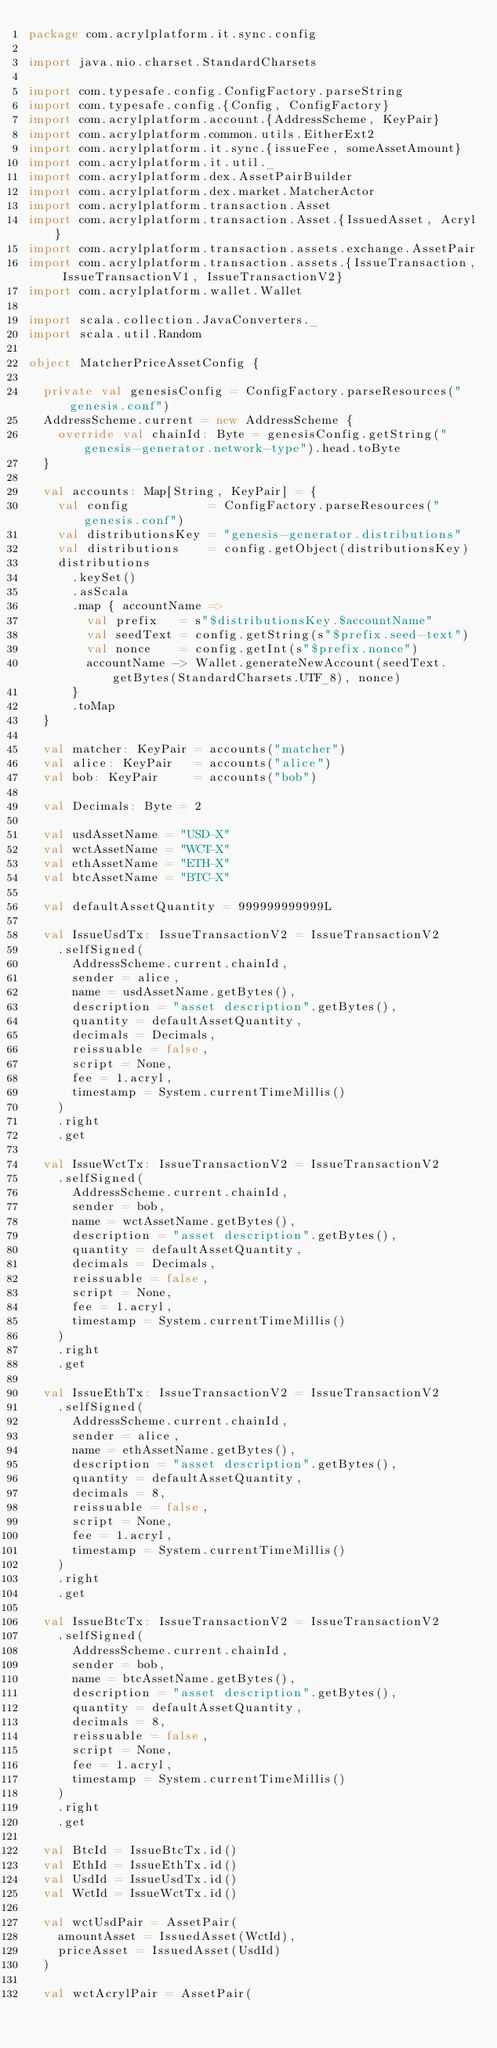Convert code to text. <code><loc_0><loc_0><loc_500><loc_500><_Scala_>package com.acrylplatform.it.sync.config

import java.nio.charset.StandardCharsets

import com.typesafe.config.ConfigFactory.parseString
import com.typesafe.config.{Config, ConfigFactory}
import com.acrylplatform.account.{AddressScheme, KeyPair}
import com.acrylplatform.common.utils.EitherExt2
import com.acrylplatform.it.sync.{issueFee, someAssetAmount}
import com.acrylplatform.it.util._
import com.acrylplatform.dex.AssetPairBuilder
import com.acrylplatform.dex.market.MatcherActor
import com.acrylplatform.transaction.Asset
import com.acrylplatform.transaction.Asset.{IssuedAsset, Acryl}
import com.acrylplatform.transaction.assets.exchange.AssetPair
import com.acrylplatform.transaction.assets.{IssueTransaction, IssueTransactionV1, IssueTransactionV2}
import com.acrylplatform.wallet.Wallet

import scala.collection.JavaConverters._
import scala.util.Random

object MatcherPriceAssetConfig {

  private val genesisConfig = ConfigFactory.parseResources("genesis.conf")
  AddressScheme.current = new AddressScheme {
    override val chainId: Byte = genesisConfig.getString("genesis-generator.network-type").head.toByte
  }

  val accounts: Map[String, KeyPair] = {
    val config           = ConfigFactory.parseResources("genesis.conf")
    val distributionsKey = "genesis-generator.distributions"
    val distributions    = config.getObject(distributionsKey)
    distributions
      .keySet()
      .asScala
      .map { accountName =>
        val prefix   = s"$distributionsKey.$accountName"
        val seedText = config.getString(s"$prefix.seed-text")
        val nonce    = config.getInt(s"$prefix.nonce")
        accountName -> Wallet.generateNewAccount(seedText.getBytes(StandardCharsets.UTF_8), nonce)
      }
      .toMap
  }

  val matcher: KeyPair = accounts("matcher")
  val alice: KeyPair   = accounts("alice")
  val bob: KeyPair     = accounts("bob")

  val Decimals: Byte = 2

  val usdAssetName = "USD-X"
  val wctAssetName = "WCT-X"
  val ethAssetName = "ETH-X"
  val btcAssetName = "BTC-X"

  val defaultAssetQuantity = 999999999999L

  val IssueUsdTx: IssueTransactionV2 = IssueTransactionV2
    .selfSigned(
      AddressScheme.current.chainId,
      sender = alice,
      name = usdAssetName.getBytes(),
      description = "asset description".getBytes(),
      quantity = defaultAssetQuantity,
      decimals = Decimals,
      reissuable = false,
      script = None,
      fee = 1.acryl,
      timestamp = System.currentTimeMillis()
    )
    .right
    .get

  val IssueWctTx: IssueTransactionV2 = IssueTransactionV2
    .selfSigned(
      AddressScheme.current.chainId,
      sender = bob,
      name = wctAssetName.getBytes(),
      description = "asset description".getBytes(),
      quantity = defaultAssetQuantity,
      decimals = Decimals,
      reissuable = false,
      script = None,
      fee = 1.acryl,
      timestamp = System.currentTimeMillis()
    )
    .right
    .get

  val IssueEthTx: IssueTransactionV2 = IssueTransactionV2
    .selfSigned(
      AddressScheme.current.chainId,
      sender = alice,
      name = ethAssetName.getBytes(),
      description = "asset description".getBytes(),
      quantity = defaultAssetQuantity,
      decimals = 8,
      reissuable = false,
      script = None,
      fee = 1.acryl,
      timestamp = System.currentTimeMillis()
    )
    .right
    .get

  val IssueBtcTx: IssueTransactionV2 = IssueTransactionV2
    .selfSigned(
      AddressScheme.current.chainId,
      sender = bob,
      name = btcAssetName.getBytes(),
      description = "asset description".getBytes(),
      quantity = defaultAssetQuantity,
      decimals = 8,
      reissuable = false,
      script = None,
      fee = 1.acryl,
      timestamp = System.currentTimeMillis()
    )
    .right
    .get

  val BtcId = IssueBtcTx.id()
  val EthId = IssueEthTx.id()
  val UsdId = IssueUsdTx.id()
  val WctId = IssueWctTx.id()

  val wctUsdPair = AssetPair(
    amountAsset = IssuedAsset(WctId),
    priceAsset = IssuedAsset(UsdId)
  )

  val wctAcrylPair = AssetPair(</code> 